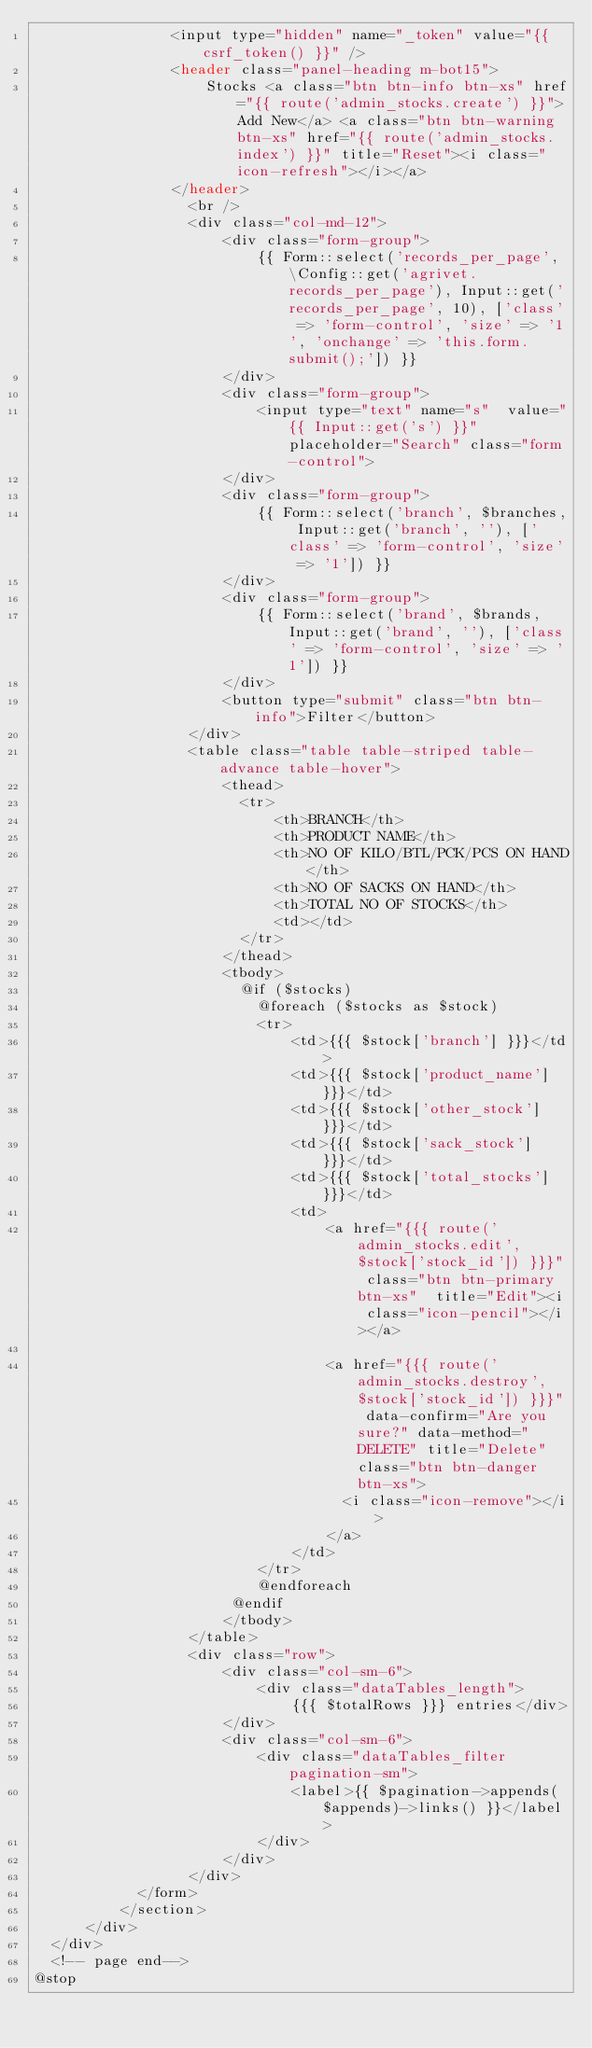Convert code to text. <code><loc_0><loc_0><loc_500><loc_500><_PHP_>                <input type="hidden" name="_token" value="{{ csrf_token() }}" />
                <header class="panel-heading m-bot15">
                    Stocks <a class="btn btn-info btn-xs" href="{{ route('admin_stocks.create') }}">Add New</a> <a class="btn btn-warning btn-xs" href="{{ route('admin_stocks.index') }}" title="Reset"><i class=" icon-refresh"></i></a>
                </header>
                  <br />
                  <div class="col-md-12">
                      <div class="form-group">
                          {{ Form::select('records_per_page', \Config::get('agrivet.records_per_page'), Input::get('records_per_page', 10), ['class' => 'form-control', 'size' => '1', 'onchange' => 'this.form.submit();']) }}
                      </div>
                      <div class="form-group">
                          <input type="text" name="s"  value="{{ Input::get('s') }}" placeholder="Search" class="form-control">
                      </div>
                      <div class="form-group">
                          {{ Form::select('branch', $branches, Input::get('branch', ''), ['class' => 'form-control', 'size' => '1']) }}
                      </div>
                      <div class="form-group">
                          {{ Form::select('brand', $brands, Input::get('brand', ''), ['class' => 'form-control', 'size' => '1']) }}
                      </div>
                      <button type="submit" class="btn btn-info">Filter</button>
                  </div>
                  <table class="table table-striped table-advance table-hover">
                      <thead>
                        <tr>
                            <th>BRANCH</th>
                            <th>PRODUCT NAME</th>
                            <th>NO OF KILO/BTL/PCK/PCS ON HAND</th>
                            <th>NO OF SACKS ON HAND</th>
                            <th>TOTAL NO OF STOCKS</th>
                            <td></td>
                        </tr>
                      </thead>
                      <tbody>
                        @if ($stocks)
                          @foreach ($stocks as $stock)
                          <tr>
                              <td>{{{ $stock['branch'] }}}</td>
                              <td>{{{ $stock['product_name'] }}}</td>
                              <td>{{{ $stock['other_stock'] }}}</td>
                              <td>{{{ $stock['sack_stock'] }}}</td>
                              <td>{{{ $stock['total_stocks'] }}}</td>
                              <td>
                                  <a href="{{{ route('admin_stocks.edit', $stock['stock_id']) }}}" class="btn btn-primary btn-xs"  title="Edit"><i class="icon-pencil"></i></a>
                
                                  <a href="{{{ route('admin_stocks.destroy', $stock['stock_id']) }}}" data-confirm="Are you sure?" data-method="DELETE" title="Delete" class="btn btn-danger btn-xs">
                                    <i class="icon-remove"></i>
                                  </a>
                              </td>
                          </tr>
                          @endforeach
                       @endif
                      </tbody>
                  </table>
                  <div class="row">
                      <div class="col-sm-6">
                          <div class="dataTables_length">
                              {{{ $totalRows }}} entries</div>
                      </div>
                      <div class="col-sm-6">
                          <div class="dataTables_filter pagination-sm">
                              <label>{{ $pagination->appends($appends)->links() }}</label>
                          </div>
                      </div>
                  </div>
            </form>
          </section>
      </div>
  </div>
  <!-- page end-->
@stop</code> 